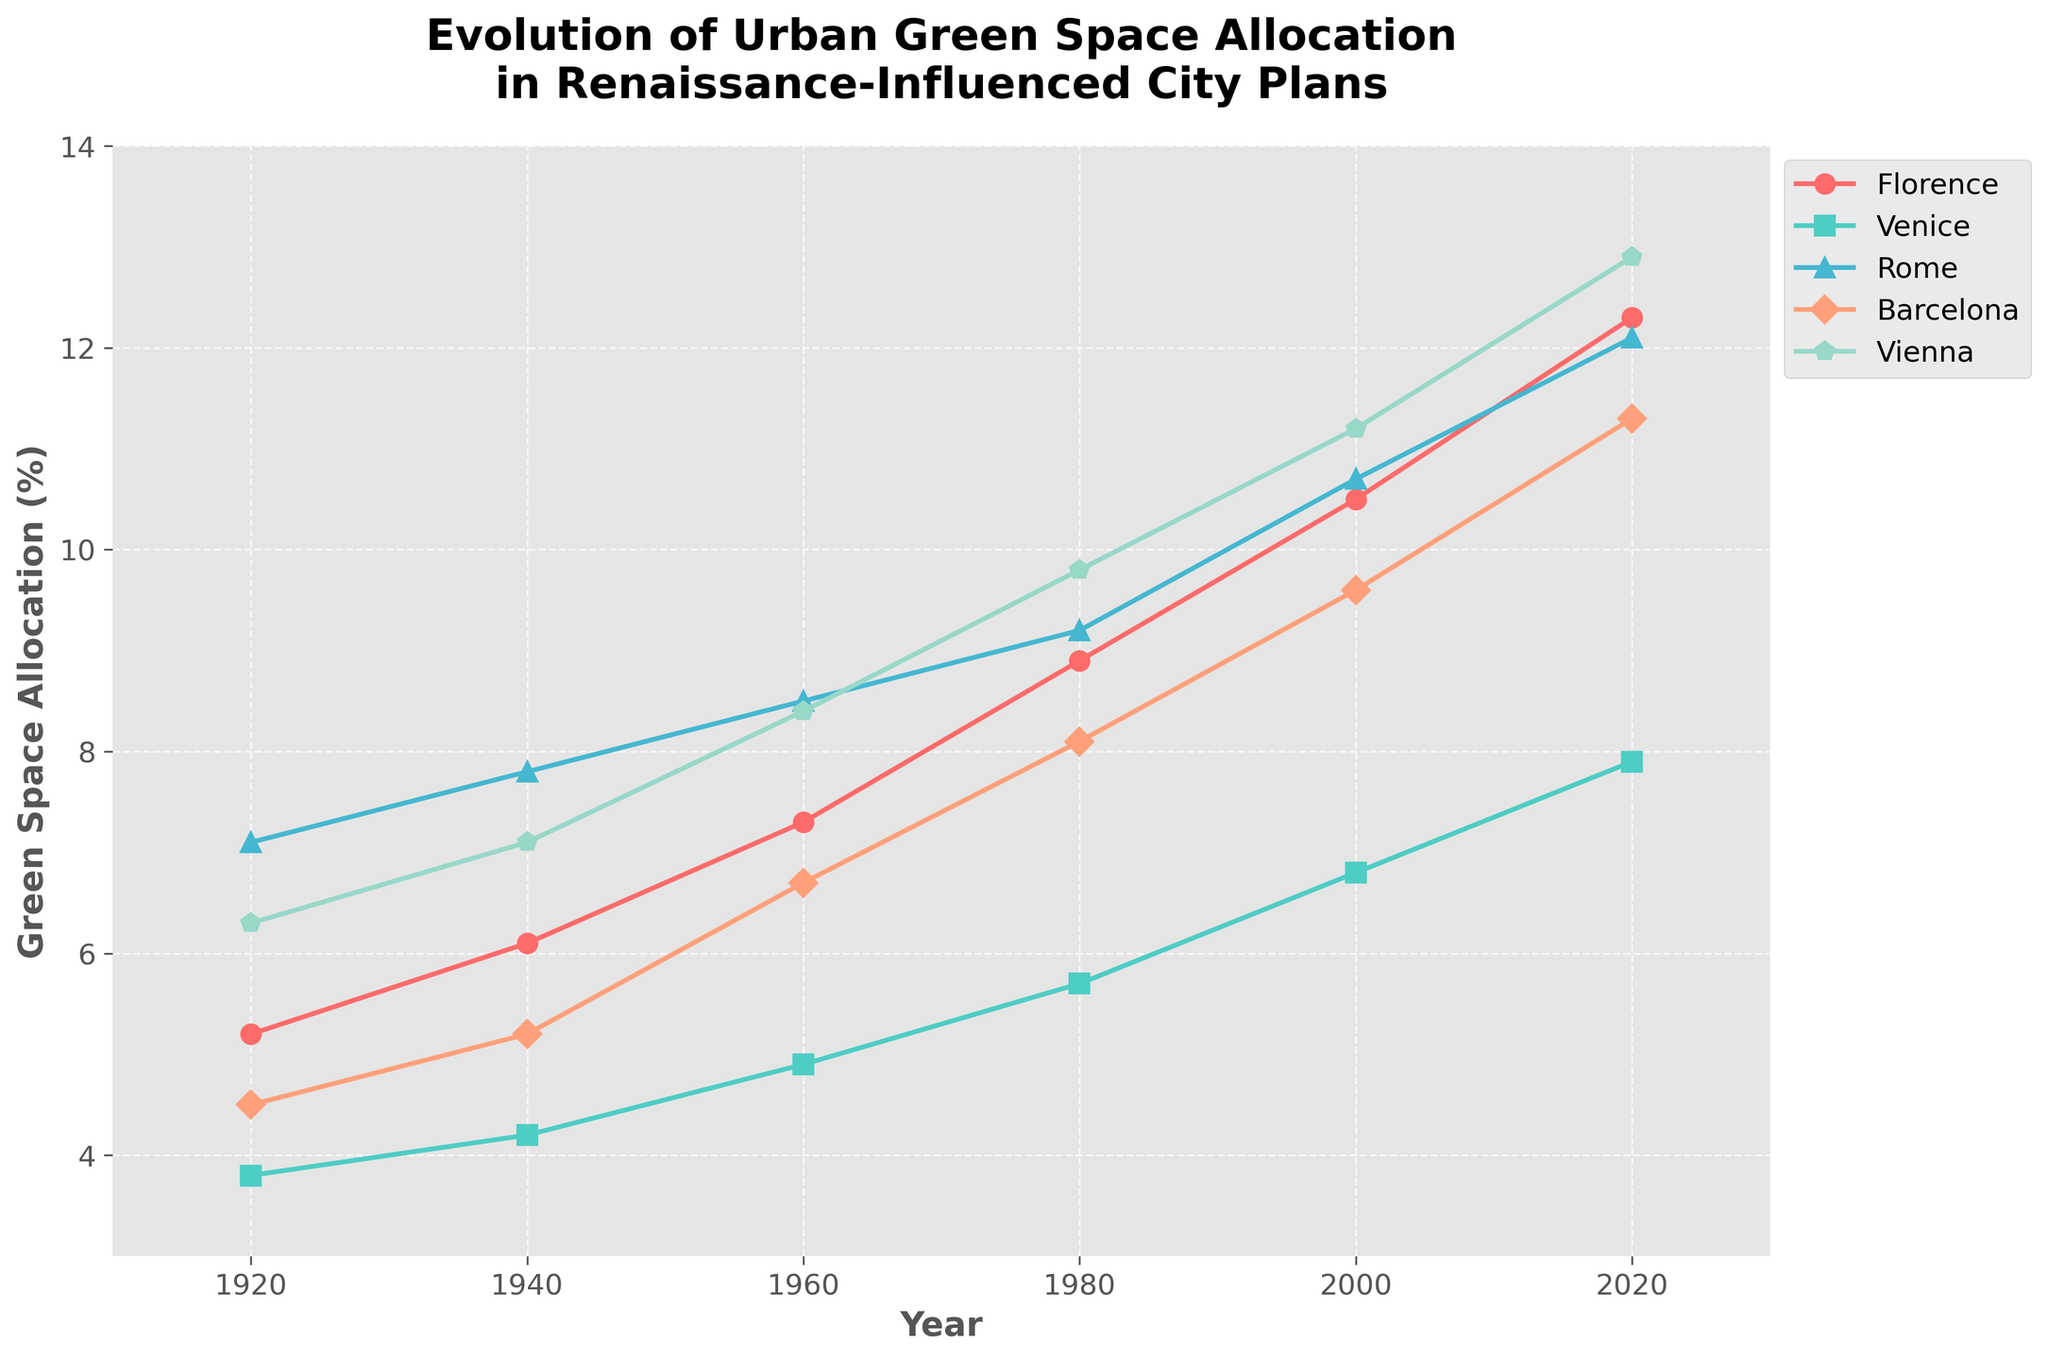Which city had the highest green space allocation in 1920? By looking at the starting points on the y-axis for each city in the year 1920, we can see that Rome had the highest value at 7.1%.
Answer: Rome Which two cities show the greatest increase in green space allocation from 1920 to 2020? To find the greatest increase, we subtract the 1920 value from the 2020 value for each city and compare them: Florence (12.3 - 5.2 = 7.1), Venice (7.9 - 3.8 = 4.1), Rome (12.1 - 7.1 = 5), Barcelona (11.3 - 4.5 = 6.8), Vienna (12.9 - 6.3 = 6.6). Thus, Florence and Barcelona show the greatest increase.
Answer: Florence and Barcelona What is the average green space allocation for Venice over the observed years? We sum the values for Venice and divide by the number of years: (3.8 + 4.2 + 4.9 + 5.7 + 6.8 + 7.9) / 6 = 33.3 / 6 = 5.55.
Answer: 5.55 Which city had a lower green space allocation in 1940 than in 1960, but higher than in 1920? By comparing the values in 1940 and 1960, Venice increased from 4.2 to 4.9. Then comparing 1940 to 1920, Venice increased from 3.8 to 4.2. Hence, Venice had a lower allocation in 1940 than in 1960, but higher than in 1920.
Answer: Venice Describe the overall trend of green space allocation in Vienna over the past century. The values for Vienna from 1920 to 2020 are consistently increasing (6.3, 7.1, 8.4, 9.8, 11.2, 12.9). This indicates a steady upward trend in green space allocation.
Answer: Increasing trend What was the difference in green space allocation between Florence and Barcelona in 2000? In 2000, Florence had 10.5% and Barcelona had 9.6%. Subtract Barcelona's value from Florence's: 10.5 - 9.6 = 0.9.
Answer: 0.9 Which city had an equal green space allocation to Venice in any of the observed years? Looking at the green space allocation for each city over time, we observe that none of the other cities have an equal value to Venice in any year.
Answer: None Compare the trend of green space allocation in Florence and Rome from 1920 to 2020. Both Florence and Rome start with an upward trend. Florence has a smooth and steady increase from 5.2% to 12.3%, while Rome increases from 7.1% to 12.1%, with both trends showing significant growth over the century.
Answer: Both increasing In which decade did Barcelona experience the most significant increase in green space allocation? By examining the increments decade by decade: 1920-1940 (0.7), 1940-1960 (1.5), 1960-1980 (1.4), 1980-2000 (1.5), 2000-2020 (1.7). The most significant increase occurred in the decade from 2000 to 2020.
Answer: 2000-2020 